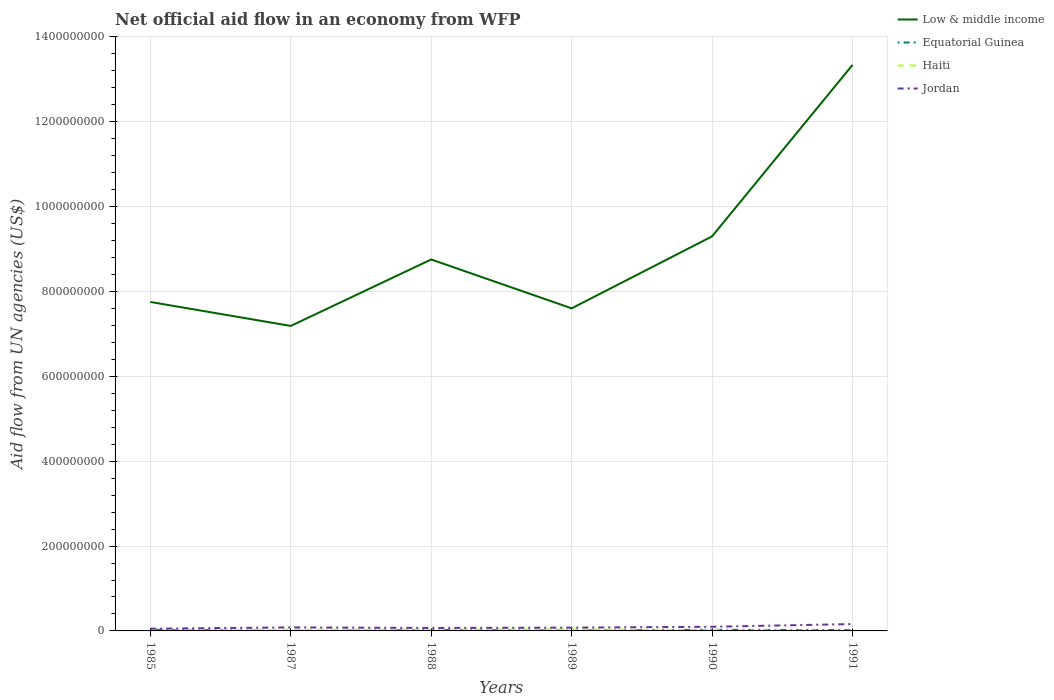How many different coloured lines are there?
Your answer should be compact. 4. Is the number of lines equal to the number of legend labels?
Offer a very short reply. Yes. Across all years, what is the maximum net official aid flow in Equatorial Guinea?
Provide a short and direct response. 8.00e+04. In which year was the net official aid flow in Jordan maximum?
Your response must be concise. 1985. What is the total net official aid flow in Haiti in the graph?
Your answer should be very brief. -1.07e+06. What is the difference between the highest and the second highest net official aid flow in Haiti?
Your response must be concise. 3.22e+06. What is the difference between the highest and the lowest net official aid flow in Haiti?
Provide a succinct answer. 3. Is the net official aid flow in Low & middle income strictly greater than the net official aid flow in Haiti over the years?
Your response must be concise. No. Where does the legend appear in the graph?
Offer a terse response. Top right. How many legend labels are there?
Offer a terse response. 4. How are the legend labels stacked?
Ensure brevity in your answer.  Vertical. What is the title of the graph?
Your answer should be very brief. Net official aid flow in an economy from WFP. Does "Upper middle income" appear as one of the legend labels in the graph?
Offer a very short reply. No. What is the label or title of the Y-axis?
Offer a very short reply. Aid flow from UN agencies (US$). What is the Aid flow from UN agencies (US$) of Low & middle income in 1985?
Give a very brief answer. 7.75e+08. What is the Aid flow from UN agencies (US$) in Equatorial Guinea in 1985?
Your response must be concise. 2.84e+06. What is the Aid flow from UN agencies (US$) in Haiti in 1985?
Offer a very short reply. 8.60e+05. What is the Aid flow from UN agencies (US$) in Jordan in 1985?
Your answer should be compact. 5.23e+06. What is the Aid flow from UN agencies (US$) of Low & middle income in 1987?
Provide a succinct answer. 7.19e+08. What is the Aid flow from UN agencies (US$) in Equatorial Guinea in 1987?
Make the answer very short. 8.00e+04. What is the Aid flow from UN agencies (US$) in Haiti in 1987?
Provide a succinct answer. 2.78e+06. What is the Aid flow from UN agencies (US$) in Jordan in 1987?
Your answer should be very brief. 8.27e+06. What is the Aid flow from UN agencies (US$) of Low & middle income in 1988?
Your response must be concise. 8.76e+08. What is the Aid flow from UN agencies (US$) in Equatorial Guinea in 1988?
Provide a short and direct response. 2.02e+06. What is the Aid flow from UN agencies (US$) of Haiti in 1988?
Offer a very short reply. 2.78e+06. What is the Aid flow from UN agencies (US$) of Jordan in 1988?
Your response must be concise. 7.02e+06. What is the Aid flow from UN agencies (US$) in Low & middle income in 1989?
Keep it short and to the point. 7.60e+08. What is the Aid flow from UN agencies (US$) of Equatorial Guinea in 1989?
Your answer should be compact. 1.14e+06. What is the Aid flow from UN agencies (US$) of Haiti in 1989?
Ensure brevity in your answer.  3.85e+06. What is the Aid flow from UN agencies (US$) in Jordan in 1989?
Offer a very short reply. 7.75e+06. What is the Aid flow from UN agencies (US$) in Low & middle income in 1990?
Provide a short and direct response. 9.30e+08. What is the Aid flow from UN agencies (US$) of Equatorial Guinea in 1990?
Give a very brief answer. 2.63e+06. What is the Aid flow from UN agencies (US$) in Haiti in 1990?
Your response must be concise. 1.72e+06. What is the Aid flow from UN agencies (US$) in Jordan in 1990?
Keep it short and to the point. 9.81e+06. What is the Aid flow from UN agencies (US$) in Low & middle income in 1991?
Your response must be concise. 1.33e+09. What is the Aid flow from UN agencies (US$) of Equatorial Guinea in 1991?
Your answer should be very brief. 2.19e+06. What is the Aid flow from UN agencies (US$) in Haiti in 1991?
Offer a very short reply. 6.30e+05. What is the Aid flow from UN agencies (US$) of Jordan in 1991?
Your answer should be compact. 1.62e+07. Across all years, what is the maximum Aid flow from UN agencies (US$) of Low & middle income?
Your response must be concise. 1.33e+09. Across all years, what is the maximum Aid flow from UN agencies (US$) of Equatorial Guinea?
Offer a very short reply. 2.84e+06. Across all years, what is the maximum Aid flow from UN agencies (US$) in Haiti?
Offer a very short reply. 3.85e+06. Across all years, what is the maximum Aid flow from UN agencies (US$) in Jordan?
Your response must be concise. 1.62e+07. Across all years, what is the minimum Aid flow from UN agencies (US$) of Low & middle income?
Offer a terse response. 7.19e+08. Across all years, what is the minimum Aid flow from UN agencies (US$) of Equatorial Guinea?
Your response must be concise. 8.00e+04. Across all years, what is the minimum Aid flow from UN agencies (US$) in Haiti?
Make the answer very short. 6.30e+05. Across all years, what is the minimum Aid flow from UN agencies (US$) of Jordan?
Offer a terse response. 5.23e+06. What is the total Aid flow from UN agencies (US$) of Low & middle income in the graph?
Ensure brevity in your answer.  5.39e+09. What is the total Aid flow from UN agencies (US$) in Equatorial Guinea in the graph?
Make the answer very short. 1.09e+07. What is the total Aid flow from UN agencies (US$) of Haiti in the graph?
Ensure brevity in your answer.  1.26e+07. What is the total Aid flow from UN agencies (US$) in Jordan in the graph?
Provide a succinct answer. 5.43e+07. What is the difference between the Aid flow from UN agencies (US$) in Low & middle income in 1985 and that in 1987?
Your response must be concise. 5.65e+07. What is the difference between the Aid flow from UN agencies (US$) in Equatorial Guinea in 1985 and that in 1987?
Provide a short and direct response. 2.76e+06. What is the difference between the Aid flow from UN agencies (US$) in Haiti in 1985 and that in 1987?
Your answer should be very brief. -1.92e+06. What is the difference between the Aid flow from UN agencies (US$) of Jordan in 1985 and that in 1987?
Offer a very short reply. -3.04e+06. What is the difference between the Aid flow from UN agencies (US$) in Low & middle income in 1985 and that in 1988?
Keep it short and to the point. -1.00e+08. What is the difference between the Aid flow from UN agencies (US$) in Equatorial Guinea in 1985 and that in 1988?
Offer a very short reply. 8.20e+05. What is the difference between the Aid flow from UN agencies (US$) of Haiti in 1985 and that in 1988?
Give a very brief answer. -1.92e+06. What is the difference between the Aid flow from UN agencies (US$) of Jordan in 1985 and that in 1988?
Offer a very short reply. -1.79e+06. What is the difference between the Aid flow from UN agencies (US$) of Low & middle income in 1985 and that in 1989?
Your response must be concise. 1.51e+07. What is the difference between the Aid flow from UN agencies (US$) of Equatorial Guinea in 1985 and that in 1989?
Offer a very short reply. 1.70e+06. What is the difference between the Aid flow from UN agencies (US$) of Haiti in 1985 and that in 1989?
Offer a terse response. -2.99e+06. What is the difference between the Aid flow from UN agencies (US$) in Jordan in 1985 and that in 1989?
Give a very brief answer. -2.52e+06. What is the difference between the Aid flow from UN agencies (US$) of Low & middle income in 1985 and that in 1990?
Provide a short and direct response. -1.55e+08. What is the difference between the Aid flow from UN agencies (US$) in Haiti in 1985 and that in 1990?
Keep it short and to the point. -8.60e+05. What is the difference between the Aid flow from UN agencies (US$) of Jordan in 1985 and that in 1990?
Your response must be concise. -4.58e+06. What is the difference between the Aid flow from UN agencies (US$) in Low & middle income in 1985 and that in 1991?
Provide a succinct answer. -5.59e+08. What is the difference between the Aid flow from UN agencies (US$) in Equatorial Guinea in 1985 and that in 1991?
Your answer should be compact. 6.50e+05. What is the difference between the Aid flow from UN agencies (US$) in Haiti in 1985 and that in 1991?
Your answer should be compact. 2.30e+05. What is the difference between the Aid flow from UN agencies (US$) in Jordan in 1985 and that in 1991?
Ensure brevity in your answer.  -1.10e+07. What is the difference between the Aid flow from UN agencies (US$) of Low & middle income in 1987 and that in 1988?
Ensure brevity in your answer.  -1.57e+08. What is the difference between the Aid flow from UN agencies (US$) of Equatorial Guinea in 1987 and that in 1988?
Provide a short and direct response. -1.94e+06. What is the difference between the Aid flow from UN agencies (US$) of Haiti in 1987 and that in 1988?
Ensure brevity in your answer.  0. What is the difference between the Aid flow from UN agencies (US$) in Jordan in 1987 and that in 1988?
Provide a succinct answer. 1.25e+06. What is the difference between the Aid flow from UN agencies (US$) in Low & middle income in 1987 and that in 1989?
Make the answer very short. -4.15e+07. What is the difference between the Aid flow from UN agencies (US$) of Equatorial Guinea in 1987 and that in 1989?
Your answer should be compact. -1.06e+06. What is the difference between the Aid flow from UN agencies (US$) in Haiti in 1987 and that in 1989?
Keep it short and to the point. -1.07e+06. What is the difference between the Aid flow from UN agencies (US$) of Jordan in 1987 and that in 1989?
Offer a terse response. 5.20e+05. What is the difference between the Aid flow from UN agencies (US$) in Low & middle income in 1987 and that in 1990?
Offer a terse response. -2.11e+08. What is the difference between the Aid flow from UN agencies (US$) in Equatorial Guinea in 1987 and that in 1990?
Make the answer very short. -2.55e+06. What is the difference between the Aid flow from UN agencies (US$) in Haiti in 1987 and that in 1990?
Give a very brief answer. 1.06e+06. What is the difference between the Aid flow from UN agencies (US$) in Jordan in 1987 and that in 1990?
Ensure brevity in your answer.  -1.54e+06. What is the difference between the Aid flow from UN agencies (US$) of Low & middle income in 1987 and that in 1991?
Your response must be concise. -6.15e+08. What is the difference between the Aid flow from UN agencies (US$) in Equatorial Guinea in 1987 and that in 1991?
Your answer should be compact. -2.11e+06. What is the difference between the Aid flow from UN agencies (US$) of Haiti in 1987 and that in 1991?
Provide a succinct answer. 2.15e+06. What is the difference between the Aid flow from UN agencies (US$) in Jordan in 1987 and that in 1991?
Provide a succinct answer. -7.91e+06. What is the difference between the Aid flow from UN agencies (US$) of Low & middle income in 1988 and that in 1989?
Your answer should be compact. 1.15e+08. What is the difference between the Aid flow from UN agencies (US$) in Equatorial Guinea in 1988 and that in 1989?
Provide a short and direct response. 8.80e+05. What is the difference between the Aid flow from UN agencies (US$) in Haiti in 1988 and that in 1989?
Provide a succinct answer. -1.07e+06. What is the difference between the Aid flow from UN agencies (US$) of Jordan in 1988 and that in 1989?
Your response must be concise. -7.30e+05. What is the difference between the Aid flow from UN agencies (US$) in Low & middle income in 1988 and that in 1990?
Make the answer very short. -5.45e+07. What is the difference between the Aid flow from UN agencies (US$) in Equatorial Guinea in 1988 and that in 1990?
Offer a terse response. -6.10e+05. What is the difference between the Aid flow from UN agencies (US$) of Haiti in 1988 and that in 1990?
Offer a terse response. 1.06e+06. What is the difference between the Aid flow from UN agencies (US$) of Jordan in 1988 and that in 1990?
Provide a succinct answer. -2.79e+06. What is the difference between the Aid flow from UN agencies (US$) of Low & middle income in 1988 and that in 1991?
Your response must be concise. -4.59e+08. What is the difference between the Aid flow from UN agencies (US$) in Equatorial Guinea in 1988 and that in 1991?
Provide a short and direct response. -1.70e+05. What is the difference between the Aid flow from UN agencies (US$) in Haiti in 1988 and that in 1991?
Give a very brief answer. 2.15e+06. What is the difference between the Aid flow from UN agencies (US$) in Jordan in 1988 and that in 1991?
Offer a very short reply. -9.16e+06. What is the difference between the Aid flow from UN agencies (US$) of Low & middle income in 1989 and that in 1990?
Your answer should be very brief. -1.70e+08. What is the difference between the Aid flow from UN agencies (US$) of Equatorial Guinea in 1989 and that in 1990?
Provide a short and direct response. -1.49e+06. What is the difference between the Aid flow from UN agencies (US$) of Haiti in 1989 and that in 1990?
Provide a short and direct response. 2.13e+06. What is the difference between the Aid flow from UN agencies (US$) of Jordan in 1989 and that in 1990?
Your answer should be compact. -2.06e+06. What is the difference between the Aid flow from UN agencies (US$) in Low & middle income in 1989 and that in 1991?
Make the answer very short. -5.74e+08. What is the difference between the Aid flow from UN agencies (US$) of Equatorial Guinea in 1989 and that in 1991?
Your answer should be compact. -1.05e+06. What is the difference between the Aid flow from UN agencies (US$) of Haiti in 1989 and that in 1991?
Provide a short and direct response. 3.22e+06. What is the difference between the Aid flow from UN agencies (US$) in Jordan in 1989 and that in 1991?
Your answer should be compact. -8.43e+06. What is the difference between the Aid flow from UN agencies (US$) of Low & middle income in 1990 and that in 1991?
Ensure brevity in your answer.  -4.04e+08. What is the difference between the Aid flow from UN agencies (US$) in Equatorial Guinea in 1990 and that in 1991?
Your response must be concise. 4.40e+05. What is the difference between the Aid flow from UN agencies (US$) in Haiti in 1990 and that in 1991?
Provide a short and direct response. 1.09e+06. What is the difference between the Aid flow from UN agencies (US$) in Jordan in 1990 and that in 1991?
Provide a succinct answer. -6.37e+06. What is the difference between the Aid flow from UN agencies (US$) in Low & middle income in 1985 and the Aid flow from UN agencies (US$) in Equatorial Guinea in 1987?
Your answer should be compact. 7.75e+08. What is the difference between the Aid flow from UN agencies (US$) of Low & middle income in 1985 and the Aid flow from UN agencies (US$) of Haiti in 1987?
Offer a very short reply. 7.73e+08. What is the difference between the Aid flow from UN agencies (US$) of Low & middle income in 1985 and the Aid flow from UN agencies (US$) of Jordan in 1987?
Offer a very short reply. 7.67e+08. What is the difference between the Aid flow from UN agencies (US$) in Equatorial Guinea in 1985 and the Aid flow from UN agencies (US$) in Haiti in 1987?
Give a very brief answer. 6.00e+04. What is the difference between the Aid flow from UN agencies (US$) of Equatorial Guinea in 1985 and the Aid flow from UN agencies (US$) of Jordan in 1987?
Make the answer very short. -5.43e+06. What is the difference between the Aid flow from UN agencies (US$) in Haiti in 1985 and the Aid flow from UN agencies (US$) in Jordan in 1987?
Keep it short and to the point. -7.41e+06. What is the difference between the Aid flow from UN agencies (US$) in Low & middle income in 1985 and the Aid flow from UN agencies (US$) in Equatorial Guinea in 1988?
Give a very brief answer. 7.73e+08. What is the difference between the Aid flow from UN agencies (US$) in Low & middle income in 1985 and the Aid flow from UN agencies (US$) in Haiti in 1988?
Your response must be concise. 7.73e+08. What is the difference between the Aid flow from UN agencies (US$) in Low & middle income in 1985 and the Aid flow from UN agencies (US$) in Jordan in 1988?
Make the answer very short. 7.68e+08. What is the difference between the Aid flow from UN agencies (US$) of Equatorial Guinea in 1985 and the Aid flow from UN agencies (US$) of Haiti in 1988?
Your answer should be very brief. 6.00e+04. What is the difference between the Aid flow from UN agencies (US$) in Equatorial Guinea in 1985 and the Aid flow from UN agencies (US$) in Jordan in 1988?
Provide a short and direct response. -4.18e+06. What is the difference between the Aid flow from UN agencies (US$) of Haiti in 1985 and the Aid flow from UN agencies (US$) of Jordan in 1988?
Your response must be concise. -6.16e+06. What is the difference between the Aid flow from UN agencies (US$) of Low & middle income in 1985 and the Aid flow from UN agencies (US$) of Equatorial Guinea in 1989?
Offer a very short reply. 7.74e+08. What is the difference between the Aid flow from UN agencies (US$) in Low & middle income in 1985 and the Aid flow from UN agencies (US$) in Haiti in 1989?
Offer a very short reply. 7.72e+08. What is the difference between the Aid flow from UN agencies (US$) in Low & middle income in 1985 and the Aid flow from UN agencies (US$) in Jordan in 1989?
Give a very brief answer. 7.68e+08. What is the difference between the Aid flow from UN agencies (US$) in Equatorial Guinea in 1985 and the Aid flow from UN agencies (US$) in Haiti in 1989?
Provide a succinct answer. -1.01e+06. What is the difference between the Aid flow from UN agencies (US$) of Equatorial Guinea in 1985 and the Aid flow from UN agencies (US$) of Jordan in 1989?
Make the answer very short. -4.91e+06. What is the difference between the Aid flow from UN agencies (US$) in Haiti in 1985 and the Aid flow from UN agencies (US$) in Jordan in 1989?
Offer a very short reply. -6.89e+06. What is the difference between the Aid flow from UN agencies (US$) of Low & middle income in 1985 and the Aid flow from UN agencies (US$) of Equatorial Guinea in 1990?
Give a very brief answer. 7.73e+08. What is the difference between the Aid flow from UN agencies (US$) in Low & middle income in 1985 and the Aid flow from UN agencies (US$) in Haiti in 1990?
Your answer should be compact. 7.74e+08. What is the difference between the Aid flow from UN agencies (US$) in Low & middle income in 1985 and the Aid flow from UN agencies (US$) in Jordan in 1990?
Your response must be concise. 7.66e+08. What is the difference between the Aid flow from UN agencies (US$) of Equatorial Guinea in 1985 and the Aid flow from UN agencies (US$) of Haiti in 1990?
Your response must be concise. 1.12e+06. What is the difference between the Aid flow from UN agencies (US$) in Equatorial Guinea in 1985 and the Aid flow from UN agencies (US$) in Jordan in 1990?
Ensure brevity in your answer.  -6.97e+06. What is the difference between the Aid flow from UN agencies (US$) of Haiti in 1985 and the Aid flow from UN agencies (US$) of Jordan in 1990?
Your answer should be compact. -8.95e+06. What is the difference between the Aid flow from UN agencies (US$) of Low & middle income in 1985 and the Aid flow from UN agencies (US$) of Equatorial Guinea in 1991?
Ensure brevity in your answer.  7.73e+08. What is the difference between the Aid flow from UN agencies (US$) in Low & middle income in 1985 and the Aid flow from UN agencies (US$) in Haiti in 1991?
Offer a very short reply. 7.75e+08. What is the difference between the Aid flow from UN agencies (US$) in Low & middle income in 1985 and the Aid flow from UN agencies (US$) in Jordan in 1991?
Provide a succinct answer. 7.59e+08. What is the difference between the Aid flow from UN agencies (US$) of Equatorial Guinea in 1985 and the Aid flow from UN agencies (US$) of Haiti in 1991?
Keep it short and to the point. 2.21e+06. What is the difference between the Aid flow from UN agencies (US$) in Equatorial Guinea in 1985 and the Aid flow from UN agencies (US$) in Jordan in 1991?
Keep it short and to the point. -1.33e+07. What is the difference between the Aid flow from UN agencies (US$) of Haiti in 1985 and the Aid flow from UN agencies (US$) of Jordan in 1991?
Give a very brief answer. -1.53e+07. What is the difference between the Aid flow from UN agencies (US$) of Low & middle income in 1987 and the Aid flow from UN agencies (US$) of Equatorial Guinea in 1988?
Ensure brevity in your answer.  7.17e+08. What is the difference between the Aid flow from UN agencies (US$) of Low & middle income in 1987 and the Aid flow from UN agencies (US$) of Haiti in 1988?
Give a very brief answer. 7.16e+08. What is the difference between the Aid flow from UN agencies (US$) of Low & middle income in 1987 and the Aid flow from UN agencies (US$) of Jordan in 1988?
Provide a succinct answer. 7.12e+08. What is the difference between the Aid flow from UN agencies (US$) of Equatorial Guinea in 1987 and the Aid flow from UN agencies (US$) of Haiti in 1988?
Your answer should be very brief. -2.70e+06. What is the difference between the Aid flow from UN agencies (US$) in Equatorial Guinea in 1987 and the Aid flow from UN agencies (US$) in Jordan in 1988?
Provide a succinct answer. -6.94e+06. What is the difference between the Aid flow from UN agencies (US$) in Haiti in 1987 and the Aid flow from UN agencies (US$) in Jordan in 1988?
Your answer should be very brief. -4.24e+06. What is the difference between the Aid flow from UN agencies (US$) of Low & middle income in 1987 and the Aid flow from UN agencies (US$) of Equatorial Guinea in 1989?
Provide a short and direct response. 7.18e+08. What is the difference between the Aid flow from UN agencies (US$) in Low & middle income in 1987 and the Aid flow from UN agencies (US$) in Haiti in 1989?
Keep it short and to the point. 7.15e+08. What is the difference between the Aid flow from UN agencies (US$) in Low & middle income in 1987 and the Aid flow from UN agencies (US$) in Jordan in 1989?
Offer a very short reply. 7.11e+08. What is the difference between the Aid flow from UN agencies (US$) of Equatorial Guinea in 1987 and the Aid flow from UN agencies (US$) of Haiti in 1989?
Your response must be concise. -3.77e+06. What is the difference between the Aid flow from UN agencies (US$) of Equatorial Guinea in 1987 and the Aid flow from UN agencies (US$) of Jordan in 1989?
Your response must be concise. -7.67e+06. What is the difference between the Aid flow from UN agencies (US$) of Haiti in 1987 and the Aid flow from UN agencies (US$) of Jordan in 1989?
Provide a short and direct response. -4.97e+06. What is the difference between the Aid flow from UN agencies (US$) of Low & middle income in 1987 and the Aid flow from UN agencies (US$) of Equatorial Guinea in 1990?
Your answer should be very brief. 7.16e+08. What is the difference between the Aid flow from UN agencies (US$) in Low & middle income in 1987 and the Aid flow from UN agencies (US$) in Haiti in 1990?
Offer a very short reply. 7.17e+08. What is the difference between the Aid flow from UN agencies (US$) in Low & middle income in 1987 and the Aid flow from UN agencies (US$) in Jordan in 1990?
Offer a terse response. 7.09e+08. What is the difference between the Aid flow from UN agencies (US$) of Equatorial Guinea in 1987 and the Aid flow from UN agencies (US$) of Haiti in 1990?
Give a very brief answer. -1.64e+06. What is the difference between the Aid flow from UN agencies (US$) of Equatorial Guinea in 1987 and the Aid flow from UN agencies (US$) of Jordan in 1990?
Keep it short and to the point. -9.73e+06. What is the difference between the Aid flow from UN agencies (US$) of Haiti in 1987 and the Aid flow from UN agencies (US$) of Jordan in 1990?
Make the answer very short. -7.03e+06. What is the difference between the Aid flow from UN agencies (US$) of Low & middle income in 1987 and the Aid flow from UN agencies (US$) of Equatorial Guinea in 1991?
Keep it short and to the point. 7.17e+08. What is the difference between the Aid flow from UN agencies (US$) of Low & middle income in 1987 and the Aid flow from UN agencies (US$) of Haiti in 1991?
Make the answer very short. 7.18e+08. What is the difference between the Aid flow from UN agencies (US$) of Low & middle income in 1987 and the Aid flow from UN agencies (US$) of Jordan in 1991?
Provide a succinct answer. 7.03e+08. What is the difference between the Aid flow from UN agencies (US$) in Equatorial Guinea in 1987 and the Aid flow from UN agencies (US$) in Haiti in 1991?
Offer a very short reply. -5.50e+05. What is the difference between the Aid flow from UN agencies (US$) in Equatorial Guinea in 1987 and the Aid flow from UN agencies (US$) in Jordan in 1991?
Give a very brief answer. -1.61e+07. What is the difference between the Aid flow from UN agencies (US$) of Haiti in 1987 and the Aid flow from UN agencies (US$) of Jordan in 1991?
Provide a succinct answer. -1.34e+07. What is the difference between the Aid flow from UN agencies (US$) of Low & middle income in 1988 and the Aid flow from UN agencies (US$) of Equatorial Guinea in 1989?
Your answer should be compact. 8.74e+08. What is the difference between the Aid flow from UN agencies (US$) in Low & middle income in 1988 and the Aid flow from UN agencies (US$) in Haiti in 1989?
Offer a terse response. 8.72e+08. What is the difference between the Aid flow from UN agencies (US$) in Low & middle income in 1988 and the Aid flow from UN agencies (US$) in Jordan in 1989?
Your answer should be compact. 8.68e+08. What is the difference between the Aid flow from UN agencies (US$) of Equatorial Guinea in 1988 and the Aid flow from UN agencies (US$) of Haiti in 1989?
Make the answer very short. -1.83e+06. What is the difference between the Aid flow from UN agencies (US$) in Equatorial Guinea in 1988 and the Aid flow from UN agencies (US$) in Jordan in 1989?
Provide a short and direct response. -5.73e+06. What is the difference between the Aid flow from UN agencies (US$) of Haiti in 1988 and the Aid flow from UN agencies (US$) of Jordan in 1989?
Ensure brevity in your answer.  -4.97e+06. What is the difference between the Aid flow from UN agencies (US$) in Low & middle income in 1988 and the Aid flow from UN agencies (US$) in Equatorial Guinea in 1990?
Make the answer very short. 8.73e+08. What is the difference between the Aid flow from UN agencies (US$) in Low & middle income in 1988 and the Aid flow from UN agencies (US$) in Haiti in 1990?
Ensure brevity in your answer.  8.74e+08. What is the difference between the Aid flow from UN agencies (US$) in Low & middle income in 1988 and the Aid flow from UN agencies (US$) in Jordan in 1990?
Your answer should be compact. 8.66e+08. What is the difference between the Aid flow from UN agencies (US$) in Equatorial Guinea in 1988 and the Aid flow from UN agencies (US$) in Jordan in 1990?
Your answer should be very brief. -7.79e+06. What is the difference between the Aid flow from UN agencies (US$) of Haiti in 1988 and the Aid flow from UN agencies (US$) of Jordan in 1990?
Offer a terse response. -7.03e+06. What is the difference between the Aid flow from UN agencies (US$) in Low & middle income in 1988 and the Aid flow from UN agencies (US$) in Equatorial Guinea in 1991?
Ensure brevity in your answer.  8.73e+08. What is the difference between the Aid flow from UN agencies (US$) in Low & middle income in 1988 and the Aid flow from UN agencies (US$) in Haiti in 1991?
Offer a terse response. 8.75e+08. What is the difference between the Aid flow from UN agencies (US$) of Low & middle income in 1988 and the Aid flow from UN agencies (US$) of Jordan in 1991?
Ensure brevity in your answer.  8.59e+08. What is the difference between the Aid flow from UN agencies (US$) in Equatorial Guinea in 1988 and the Aid flow from UN agencies (US$) in Haiti in 1991?
Offer a terse response. 1.39e+06. What is the difference between the Aid flow from UN agencies (US$) of Equatorial Guinea in 1988 and the Aid flow from UN agencies (US$) of Jordan in 1991?
Keep it short and to the point. -1.42e+07. What is the difference between the Aid flow from UN agencies (US$) in Haiti in 1988 and the Aid flow from UN agencies (US$) in Jordan in 1991?
Your answer should be compact. -1.34e+07. What is the difference between the Aid flow from UN agencies (US$) of Low & middle income in 1989 and the Aid flow from UN agencies (US$) of Equatorial Guinea in 1990?
Make the answer very short. 7.58e+08. What is the difference between the Aid flow from UN agencies (US$) in Low & middle income in 1989 and the Aid flow from UN agencies (US$) in Haiti in 1990?
Keep it short and to the point. 7.59e+08. What is the difference between the Aid flow from UN agencies (US$) of Low & middle income in 1989 and the Aid flow from UN agencies (US$) of Jordan in 1990?
Make the answer very short. 7.51e+08. What is the difference between the Aid flow from UN agencies (US$) of Equatorial Guinea in 1989 and the Aid flow from UN agencies (US$) of Haiti in 1990?
Your response must be concise. -5.80e+05. What is the difference between the Aid flow from UN agencies (US$) of Equatorial Guinea in 1989 and the Aid flow from UN agencies (US$) of Jordan in 1990?
Your response must be concise. -8.67e+06. What is the difference between the Aid flow from UN agencies (US$) of Haiti in 1989 and the Aid flow from UN agencies (US$) of Jordan in 1990?
Your answer should be very brief. -5.96e+06. What is the difference between the Aid flow from UN agencies (US$) in Low & middle income in 1989 and the Aid flow from UN agencies (US$) in Equatorial Guinea in 1991?
Offer a terse response. 7.58e+08. What is the difference between the Aid flow from UN agencies (US$) of Low & middle income in 1989 and the Aid flow from UN agencies (US$) of Haiti in 1991?
Offer a terse response. 7.60e+08. What is the difference between the Aid flow from UN agencies (US$) in Low & middle income in 1989 and the Aid flow from UN agencies (US$) in Jordan in 1991?
Give a very brief answer. 7.44e+08. What is the difference between the Aid flow from UN agencies (US$) in Equatorial Guinea in 1989 and the Aid flow from UN agencies (US$) in Haiti in 1991?
Provide a succinct answer. 5.10e+05. What is the difference between the Aid flow from UN agencies (US$) in Equatorial Guinea in 1989 and the Aid flow from UN agencies (US$) in Jordan in 1991?
Offer a terse response. -1.50e+07. What is the difference between the Aid flow from UN agencies (US$) of Haiti in 1989 and the Aid flow from UN agencies (US$) of Jordan in 1991?
Offer a terse response. -1.23e+07. What is the difference between the Aid flow from UN agencies (US$) of Low & middle income in 1990 and the Aid flow from UN agencies (US$) of Equatorial Guinea in 1991?
Keep it short and to the point. 9.28e+08. What is the difference between the Aid flow from UN agencies (US$) in Low & middle income in 1990 and the Aid flow from UN agencies (US$) in Haiti in 1991?
Offer a terse response. 9.29e+08. What is the difference between the Aid flow from UN agencies (US$) in Low & middle income in 1990 and the Aid flow from UN agencies (US$) in Jordan in 1991?
Your answer should be compact. 9.14e+08. What is the difference between the Aid flow from UN agencies (US$) in Equatorial Guinea in 1990 and the Aid flow from UN agencies (US$) in Jordan in 1991?
Offer a terse response. -1.36e+07. What is the difference between the Aid flow from UN agencies (US$) of Haiti in 1990 and the Aid flow from UN agencies (US$) of Jordan in 1991?
Keep it short and to the point. -1.45e+07. What is the average Aid flow from UN agencies (US$) in Low & middle income per year?
Your response must be concise. 8.99e+08. What is the average Aid flow from UN agencies (US$) in Equatorial Guinea per year?
Provide a succinct answer. 1.82e+06. What is the average Aid flow from UN agencies (US$) in Haiti per year?
Keep it short and to the point. 2.10e+06. What is the average Aid flow from UN agencies (US$) of Jordan per year?
Your response must be concise. 9.04e+06. In the year 1985, what is the difference between the Aid flow from UN agencies (US$) in Low & middle income and Aid flow from UN agencies (US$) in Equatorial Guinea?
Keep it short and to the point. 7.73e+08. In the year 1985, what is the difference between the Aid flow from UN agencies (US$) of Low & middle income and Aid flow from UN agencies (US$) of Haiti?
Your response must be concise. 7.75e+08. In the year 1985, what is the difference between the Aid flow from UN agencies (US$) in Low & middle income and Aid flow from UN agencies (US$) in Jordan?
Keep it short and to the point. 7.70e+08. In the year 1985, what is the difference between the Aid flow from UN agencies (US$) of Equatorial Guinea and Aid flow from UN agencies (US$) of Haiti?
Provide a short and direct response. 1.98e+06. In the year 1985, what is the difference between the Aid flow from UN agencies (US$) of Equatorial Guinea and Aid flow from UN agencies (US$) of Jordan?
Ensure brevity in your answer.  -2.39e+06. In the year 1985, what is the difference between the Aid flow from UN agencies (US$) of Haiti and Aid flow from UN agencies (US$) of Jordan?
Provide a short and direct response. -4.37e+06. In the year 1987, what is the difference between the Aid flow from UN agencies (US$) in Low & middle income and Aid flow from UN agencies (US$) in Equatorial Guinea?
Keep it short and to the point. 7.19e+08. In the year 1987, what is the difference between the Aid flow from UN agencies (US$) in Low & middle income and Aid flow from UN agencies (US$) in Haiti?
Your answer should be very brief. 7.16e+08. In the year 1987, what is the difference between the Aid flow from UN agencies (US$) of Low & middle income and Aid flow from UN agencies (US$) of Jordan?
Make the answer very short. 7.11e+08. In the year 1987, what is the difference between the Aid flow from UN agencies (US$) in Equatorial Guinea and Aid flow from UN agencies (US$) in Haiti?
Ensure brevity in your answer.  -2.70e+06. In the year 1987, what is the difference between the Aid flow from UN agencies (US$) in Equatorial Guinea and Aid flow from UN agencies (US$) in Jordan?
Your response must be concise. -8.19e+06. In the year 1987, what is the difference between the Aid flow from UN agencies (US$) in Haiti and Aid flow from UN agencies (US$) in Jordan?
Provide a short and direct response. -5.49e+06. In the year 1988, what is the difference between the Aid flow from UN agencies (US$) in Low & middle income and Aid flow from UN agencies (US$) in Equatorial Guinea?
Make the answer very short. 8.73e+08. In the year 1988, what is the difference between the Aid flow from UN agencies (US$) of Low & middle income and Aid flow from UN agencies (US$) of Haiti?
Make the answer very short. 8.73e+08. In the year 1988, what is the difference between the Aid flow from UN agencies (US$) in Low & middle income and Aid flow from UN agencies (US$) in Jordan?
Give a very brief answer. 8.68e+08. In the year 1988, what is the difference between the Aid flow from UN agencies (US$) in Equatorial Guinea and Aid flow from UN agencies (US$) in Haiti?
Provide a succinct answer. -7.60e+05. In the year 1988, what is the difference between the Aid flow from UN agencies (US$) in Equatorial Guinea and Aid flow from UN agencies (US$) in Jordan?
Offer a very short reply. -5.00e+06. In the year 1988, what is the difference between the Aid flow from UN agencies (US$) of Haiti and Aid flow from UN agencies (US$) of Jordan?
Keep it short and to the point. -4.24e+06. In the year 1989, what is the difference between the Aid flow from UN agencies (US$) in Low & middle income and Aid flow from UN agencies (US$) in Equatorial Guinea?
Your response must be concise. 7.59e+08. In the year 1989, what is the difference between the Aid flow from UN agencies (US$) in Low & middle income and Aid flow from UN agencies (US$) in Haiti?
Provide a short and direct response. 7.56e+08. In the year 1989, what is the difference between the Aid flow from UN agencies (US$) of Low & middle income and Aid flow from UN agencies (US$) of Jordan?
Your response must be concise. 7.53e+08. In the year 1989, what is the difference between the Aid flow from UN agencies (US$) of Equatorial Guinea and Aid flow from UN agencies (US$) of Haiti?
Your response must be concise. -2.71e+06. In the year 1989, what is the difference between the Aid flow from UN agencies (US$) of Equatorial Guinea and Aid flow from UN agencies (US$) of Jordan?
Keep it short and to the point. -6.61e+06. In the year 1989, what is the difference between the Aid flow from UN agencies (US$) of Haiti and Aid flow from UN agencies (US$) of Jordan?
Keep it short and to the point. -3.90e+06. In the year 1990, what is the difference between the Aid flow from UN agencies (US$) in Low & middle income and Aid flow from UN agencies (US$) in Equatorial Guinea?
Provide a short and direct response. 9.27e+08. In the year 1990, what is the difference between the Aid flow from UN agencies (US$) in Low & middle income and Aid flow from UN agencies (US$) in Haiti?
Ensure brevity in your answer.  9.28e+08. In the year 1990, what is the difference between the Aid flow from UN agencies (US$) of Low & middle income and Aid flow from UN agencies (US$) of Jordan?
Ensure brevity in your answer.  9.20e+08. In the year 1990, what is the difference between the Aid flow from UN agencies (US$) in Equatorial Guinea and Aid flow from UN agencies (US$) in Haiti?
Your answer should be very brief. 9.10e+05. In the year 1990, what is the difference between the Aid flow from UN agencies (US$) in Equatorial Guinea and Aid flow from UN agencies (US$) in Jordan?
Keep it short and to the point. -7.18e+06. In the year 1990, what is the difference between the Aid flow from UN agencies (US$) of Haiti and Aid flow from UN agencies (US$) of Jordan?
Your answer should be very brief. -8.09e+06. In the year 1991, what is the difference between the Aid flow from UN agencies (US$) in Low & middle income and Aid flow from UN agencies (US$) in Equatorial Guinea?
Ensure brevity in your answer.  1.33e+09. In the year 1991, what is the difference between the Aid flow from UN agencies (US$) in Low & middle income and Aid flow from UN agencies (US$) in Haiti?
Give a very brief answer. 1.33e+09. In the year 1991, what is the difference between the Aid flow from UN agencies (US$) in Low & middle income and Aid flow from UN agencies (US$) in Jordan?
Offer a very short reply. 1.32e+09. In the year 1991, what is the difference between the Aid flow from UN agencies (US$) in Equatorial Guinea and Aid flow from UN agencies (US$) in Haiti?
Your answer should be compact. 1.56e+06. In the year 1991, what is the difference between the Aid flow from UN agencies (US$) in Equatorial Guinea and Aid flow from UN agencies (US$) in Jordan?
Ensure brevity in your answer.  -1.40e+07. In the year 1991, what is the difference between the Aid flow from UN agencies (US$) in Haiti and Aid flow from UN agencies (US$) in Jordan?
Give a very brief answer. -1.56e+07. What is the ratio of the Aid flow from UN agencies (US$) of Low & middle income in 1985 to that in 1987?
Provide a succinct answer. 1.08. What is the ratio of the Aid flow from UN agencies (US$) in Equatorial Guinea in 1985 to that in 1987?
Your answer should be very brief. 35.5. What is the ratio of the Aid flow from UN agencies (US$) of Haiti in 1985 to that in 1987?
Keep it short and to the point. 0.31. What is the ratio of the Aid flow from UN agencies (US$) of Jordan in 1985 to that in 1987?
Your answer should be compact. 0.63. What is the ratio of the Aid flow from UN agencies (US$) in Low & middle income in 1985 to that in 1988?
Your answer should be compact. 0.89. What is the ratio of the Aid flow from UN agencies (US$) in Equatorial Guinea in 1985 to that in 1988?
Provide a succinct answer. 1.41. What is the ratio of the Aid flow from UN agencies (US$) of Haiti in 1985 to that in 1988?
Your answer should be very brief. 0.31. What is the ratio of the Aid flow from UN agencies (US$) of Jordan in 1985 to that in 1988?
Provide a short and direct response. 0.74. What is the ratio of the Aid flow from UN agencies (US$) in Low & middle income in 1985 to that in 1989?
Provide a succinct answer. 1.02. What is the ratio of the Aid flow from UN agencies (US$) of Equatorial Guinea in 1985 to that in 1989?
Make the answer very short. 2.49. What is the ratio of the Aid flow from UN agencies (US$) in Haiti in 1985 to that in 1989?
Provide a short and direct response. 0.22. What is the ratio of the Aid flow from UN agencies (US$) of Jordan in 1985 to that in 1989?
Provide a short and direct response. 0.67. What is the ratio of the Aid flow from UN agencies (US$) of Low & middle income in 1985 to that in 1990?
Your answer should be compact. 0.83. What is the ratio of the Aid flow from UN agencies (US$) in Equatorial Guinea in 1985 to that in 1990?
Your response must be concise. 1.08. What is the ratio of the Aid flow from UN agencies (US$) in Haiti in 1985 to that in 1990?
Keep it short and to the point. 0.5. What is the ratio of the Aid flow from UN agencies (US$) of Jordan in 1985 to that in 1990?
Give a very brief answer. 0.53. What is the ratio of the Aid flow from UN agencies (US$) of Low & middle income in 1985 to that in 1991?
Provide a succinct answer. 0.58. What is the ratio of the Aid flow from UN agencies (US$) in Equatorial Guinea in 1985 to that in 1991?
Offer a very short reply. 1.3. What is the ratio of the Aid flow from UN agencies (US$) of Haiti in 1985 to that in 1991?
Ensure brevity in your answer.  1.37. What is the ratio of the Aid flow from UN agencies (US$) in Jordan in 1985 to that in 1991?
Ensure brevity in your answer.  0.32. What is the ratio of the Aid flow from UN agencies (US$) of Low & middle income in 1987 to that in 1988?
Keep it short and to the point. 0.82. What is the ratio of the Aid flow from UN agencies (US$) in Equatorial Guinea in 1987 to that in 1988?
Ensure brevity in your answer.  0.04. What is the ratio of the Aid flow from UN agencies (US$) in Jordan in 1987 to that in 1988?
Your answer should be compact. 1.18. What is the ratio of the Aid flow from UN agencies (US$) of Low & middle income in 1987 to that in 1989?
Provide a succinct answer. 0.95. What is the ratio of the Aid flow from UN agencies (US$) of Equatorial Guinea in 1987 to that in 1989?
Your answer should be very brief. 0.07. What is the ratio of the Aid flow from UN agencies (US$) of Haiti in 1987 to that in 1989?
Offer a very short reply. 0.72. What is the ratio of the Aid flow from UN agencies (US$) of Jordan in 1987 to that in 1989?
Provide a succinct answer. 1.07. What is the ratio of the Aid flow from UN agencies (US$) in Low & middle income in 1987 to that in 1990?
Make the answer very short. 0.77. What is the ratio of the Aid flow from UN agencies (US$) of Equatorial Guinea in 1987 to that in 1990?
Ensure brevity in your answer.  0.03. What is the ratio of the Aid flow from UN agencies (US$) in Haiti in 1987 to that in 1990?
Give a very brief answer. 1.62. What is the ratio of the Aid flow from UN agencies (US$) of Jordan in 1987 to that in 1990?
Provide a succinct answer. 0.84. What is the ratio of the Aid flow from UN agencies (US$) in Low & middle income in 1987 to that in 1991?
Keep it short and to the point. 0.54. What is the ratio of the Aid flow from UN agencies (US$) of Equatorial Guinea in 1987 to that in 1991?
Ensure brevity in your answer.  0.04. What is the ratio of the Aid flow from UN agencies (US$) of Haiti in 1987 to that in 1991?
Your answer should be very brief. 4.41. What is the ratio of the Aid flow from UN agencies (US$) of Jordan in 1987 to that in 1991?
Provide a succinct answer. 0.51. What is the ratio of the Aid flow from UN agencies (US$) in Low & middle income in 1988 to that in 1989?
Your answer should be very brief. 1.15. What is the ratio of the Aid flow from UN agencies (US$) of Equatorial Guinea in 1988 to that in 1989?
Your answer should be very brief. 1.77. What is the ratio of the Aid flow from UN agencies (US$) of Haiti in 1988 to that in 1989?
Give a very brief answer. 0.72. What is the ratio of the Aid flow from UN agencies (US$) of Jordan in 1988 to that in 1989?
Keep it short and to the point. 0.91. What is the ratio of the Aid flow from UN agencies (US$) of Low & middle income in 1988 to that in 1990?
Provide a short and direct response. 0.94. What is the ratio of the Aid flow from UN agencies (US$) in Equatorial Guinea in 1988 to that in 1990?
Make the answer very short. 0.77. What is the ratio of the Aid flow from UN agencies (US$) in Haiti in 1988 to that in 1990?
Provide a short and direct response. 1.62. What is the ratio of the Aid flow from UN agencies (US$) of Jordan in 1988 to that in 1990?
Your answer should be very brief. 0.72. What is the ratio of the Aid flow from UN agencies (US$) of Low & middle income in 1988 to that in 1991?
Your answer should be compact. 0.66. What is the ratio of the Aid flow from UN agencies (US$) in Equatorial Guinea in 1988 to that in 1991?
Your answer should be compact. 0.92. What is the ratio of the Aid flow from UN agencies (US$) in Haiti in 1988 to that in 1991?
Your response must be concise. 4.41. What is the ratio of the Aid flow from UN agencies (US$) in Jordan in 1988 to that in 1991?
Keep it short and to the point. 0.43. What is the ratio of the Aid flow from UN agencies (US$) of Low & middle income in 1989 to that in 1990?
Ensure brevity in your answer.  0.82. What is the ratio of the Aid flow from UN agencies (US$) in Equatorial Guinea in 1989 to that in 1990?
Keep it short and to the point. 0.43. What is the ratio of the Aid flow from UN agencies (US$) in Haiti in 1989 to that in 1990?
Provide a succinct answer. 2.24. What is the ratio of the Aid flow from UN agencies (US$) of Jordan in 1989 to that in 1990?
Provide a succinct answer. 0.79. What is the ratio of the Aid flow from UN agencies (US$) in Low & middle income in 1989 to that in 1991?
Keep it short and to the point. 0.57. What is the ratio of the Aid flow from UN agencies (US$) of Equatorial Guinea in 1989 to that in 1991?
Give a very brief answer. 0.52. What is the ratio of the Aid flow from UN agencies (US$) of Haiti in 1989 to that in 1991?
Provide a short and direct response. 6.11. What is the ratio of the Aid flow from UN agencies (US$) in Jordan in 1989 to that in 1991?
Your response must be concise. 0.48. What is the ratio of the Aid flow from UN agencies (US$) in Low & middle income in 1990 to that in 1991?
Your answer should be compact. 0.7. What is the ratio of the Aid flow from UN agencies (US$) in Equatorial Guinea in 1990 to that in 1991?
Offer a terse response. 1.2. What is the ratio of the Aid flow from UN agencies (US$) of Haiti in 1990 to that in 1991?
Ensure brevity in your answer.  2.73. What is the ratio of the Aid flow from UN agencies (US$) of Jordan in 1990 to that in 1991?
Your answer should be very brief. 0.61. What is the difference between the highest and the second highest Aid flow from UN agencies (US$) of Low & middle income?
Your response must be concise. 4.04e+08. What is the difference between the highest and the second highest Aid flow from UN agencies (US$) in Equatorial Guinea?
Offer a terse response. 2.10e+05. What is the difference between the highest and the second highest Aid flow from UN agencies (US$) of Haiti?
Your answer should be very brief. 1.07e+06. What is the difference between the highest and the second highest Aid flow from UN agencies (US$) of Jordan?
Provide a succinct answer. 6.37e+06. What is the difference between the highest and the lowest Aid flow from UN agencies (US$) in Low & middle income?
Give a very brief answer. 6.15e+08. What is the difference between the highest and the lowest Aid flow from UN agencies (US$) in Equatorial Guinea?
Your answer should be very brief. 2.76e+06. What is the difference between the highest and the lowest Aid flow from UN agencies (US$) of Haiti?
Provide a succinct answer. 3.22e+06. What is the difference between the highest and the lowest Aid flow from UN agencies (US$) in Jordan?
Your response must be concise. 1.10e+07. 